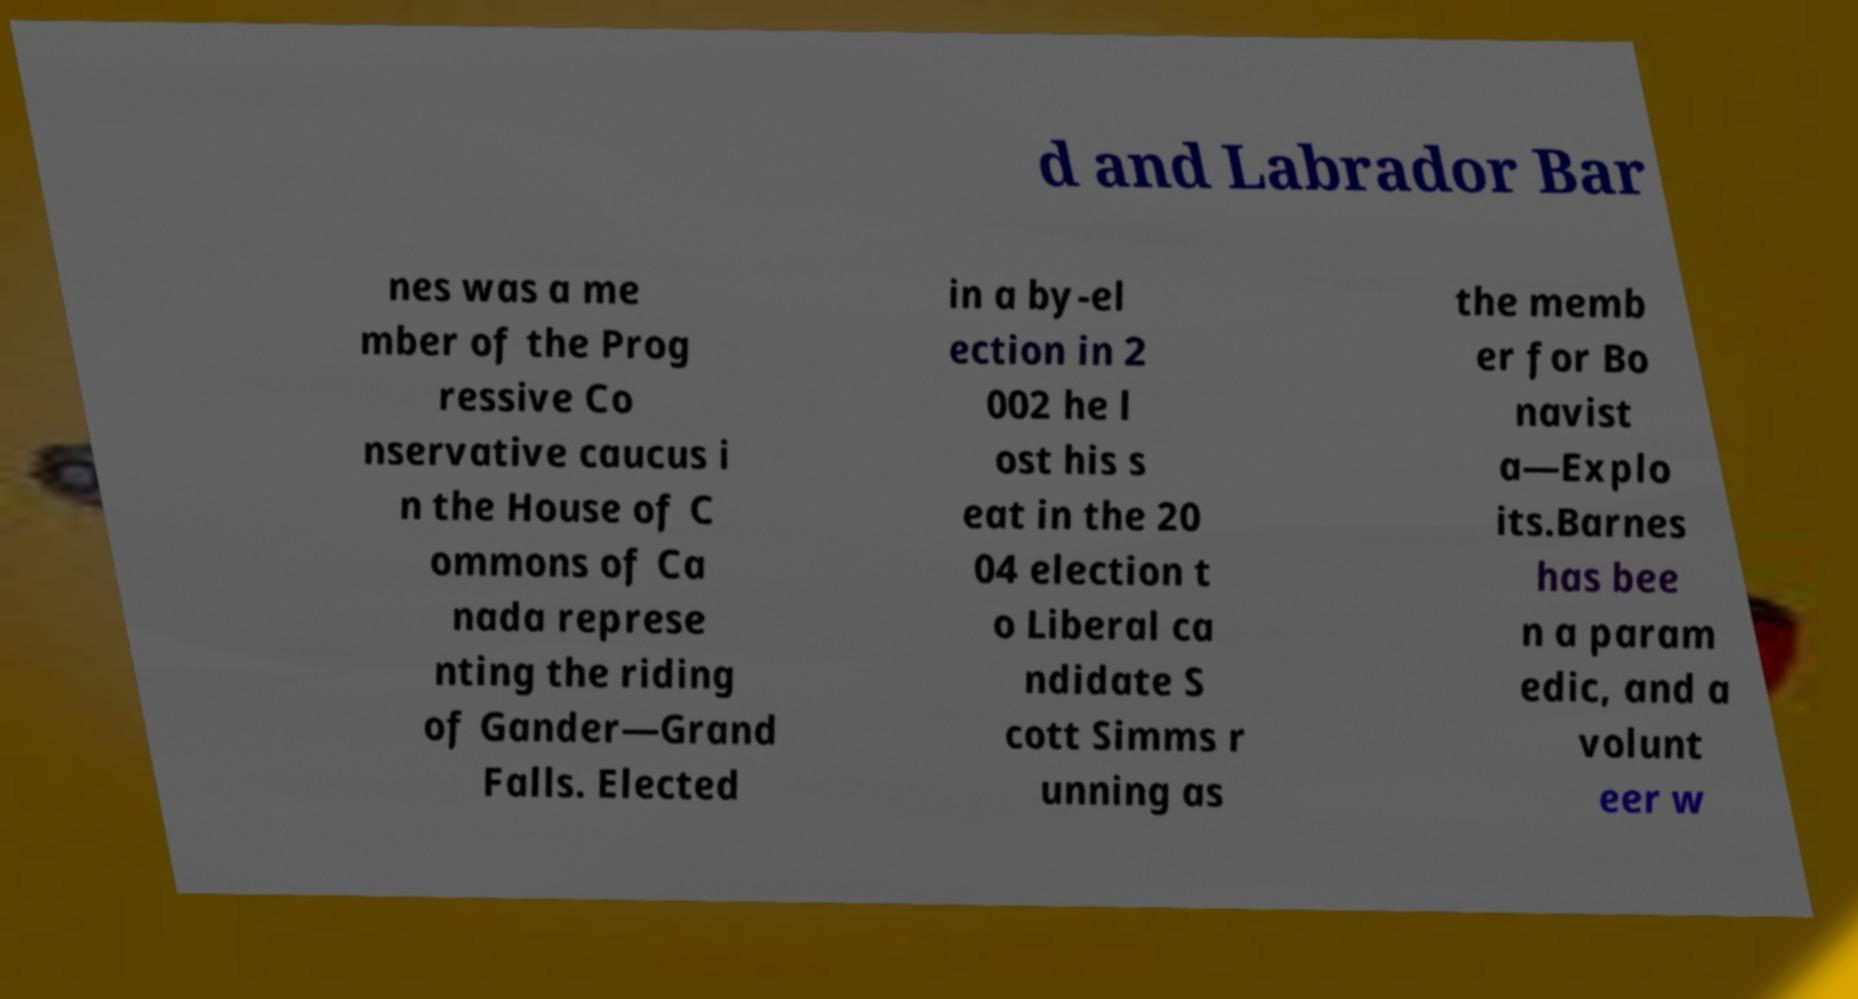There's text embedded in this image that I need extracted. Can you transcribe it verbatim? d and Labrador Bar nes was a me mber of the Prog ressive Co nservative caucus i n the House of C ommons of Ca nada represe nting the riding of Gander—Grand Falls. Elected in a by-el ection in 2 002 he l ost his s eat in the 20 04 election t o Liberal ca ndidate S cott Simms r unning as the memb er for Bo navist a—Explo its.Barnes has bee n a param edic, and a volunt eer w 